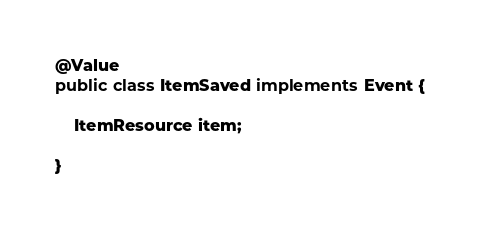Convert code to text. <code><loc_0><loc_0><loc_500><loc_500><_Java_>
@Value
public class ItemSaved implements Event {

    ItemResource item;

}
</code> 